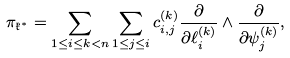<formula> <loc_0><loc_0><loc_500><loc_500>\pi _ { \mathfrak { k } ^ { * } } = \sum _ { 1 \leq i \leq k < n } \sum _ { 1 \leq j \leq i } c _ { i , j } ^ { ( k ) } \frac { \partial } { \partial \ell _ { i } ^ { ( k ) } } \wedge \frac { \partial } { \partial \psi _ { j } ^ { ( k ) } } ,</formula> 